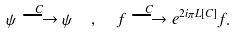Convert formula to latex. <formula><loc_0><loc_0><loc_500><loc_500>\psi \stackrel { C } { \longrightarrow } \psi \ \ , \ \ f \stackrel { C } { \longrightarrow } e ^ { 2 i \pi L [ C ] } f .</formula> 